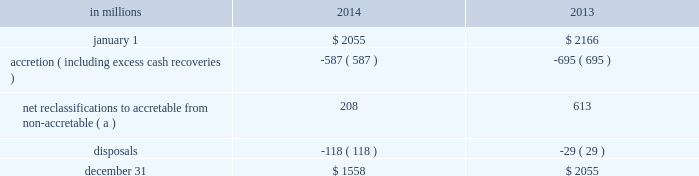During 2014 , $ 91 million of provision recapture was recorded for purchased impaired loans compared to $ 11 million of provision expense for 2013 .
The charge-offs ( which were specifically for commercial loans greater than a defined threshold ) during 2014 were $ 42 million compared to $ 104 million for 2013 .
At december 31 , 2014 , the allowance for loan and lease losses was $ .9 billion on $ 4.4 billion of purchased impaired loans while the remaining $ .5 billion of purchased impaired loans required no allowance as the net present value of expected cash flows equaled or exceeded the recorded investment .
As of december 31 , 2013 , the allowance for loan and lease losses related to purchased impaired loans was $ 1.0 billion .
If any allowance for loan losses is recognized on a purchased impaired pool , which is accounted for as a single asset , the entire balance of that pool would be disclosed as requiring an allowance .
Subsequent increases in the net present value of cash flows will result in a provision recapture of any previously recorded allowance for loan and lease losses , to the extent applicable , and/or a reclassification from non-accretable difference to accretable yield , which will be recognized prospectively .
Individual loan transactions where final dispositions have occurred ( as noted above ) result in removal of the loans from their applicable pools for cash flow estimation purposes .
The cash flow re-estimation process is completed quarterly to evaluate the appropriateness of the allowance associated with the purchased impaired loans .
Activity for the accretable yield during 2014 and 2013 follows : table 72 : purchased impaired loans 2013 accretable yield .
( a ) approximately 93% ( 93 % ) of net reclassifications for the year ended december 31 , 2014 were within the commercial portfolio as compared to 37% ( 37 % ) for year ended december 31 , 2013 .
Note 5 allowances for loan and lease losses and unfunded loan commitments and letters of credit allowance for loan and lease losses we maintain the alll at levels that we believe to be appropriate to absorb estimated probable credit losses incurred in the portfolios as of the balance sheet date .
We use the two main portfolio segments 2013 commercial lending and consumer lending 2013 and develop and document the alll under separate methodologies for each of these segments as discussed in note 1 accounting policies .
A rollforward of the alll and associated loan data is presented below .
The pnc financial services group , inc .
2013 form 10-k 143 .
What was the dollar amount in millions for net reclassifications for the year ended december 31 , 2013 due to the commercial portfolio? 
Computations: (2055 * 37%)
Answer: 760.35. 